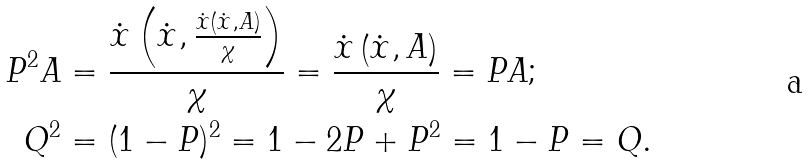<formula> <loc_0><loc_0><loc_500><loc_500>P ^ { 2 } A & = \frac { \dot { x } \left ( \dot { x } , \frac { \dot { x } \left ( \dot { x } , A \right ) } { \chi } \right ) } { \chi } = \frac { \dot { x } \left ( \dot { x } , A \right ) } { \chi } = P A ; \\ Q ^ { 2 } & = ( 1 - P ) ^ { 2 } = 1 - 2 P + P ^ { 2 } = 1 - P = Q .</formula> 